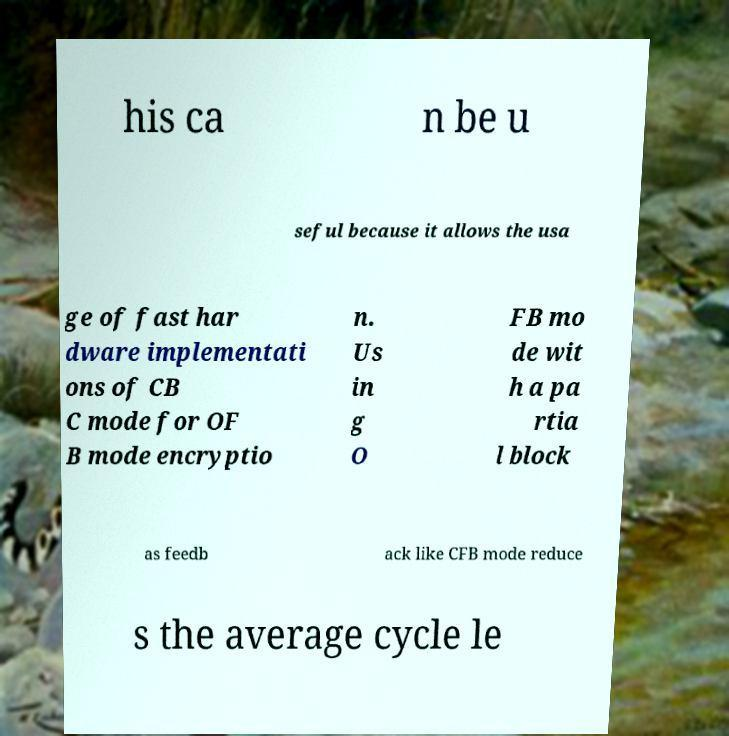What messages or text are displayed in this image? I need them in a readable, typed format. his ca n be u seful because it allows the usa ge of fast har dware implementati ons of CB C mode for OF B mode encryptio n. Us in g O FB mo de wit h a pa rtia l block as feedb ack like CFB mode reduce s the average cycle le 